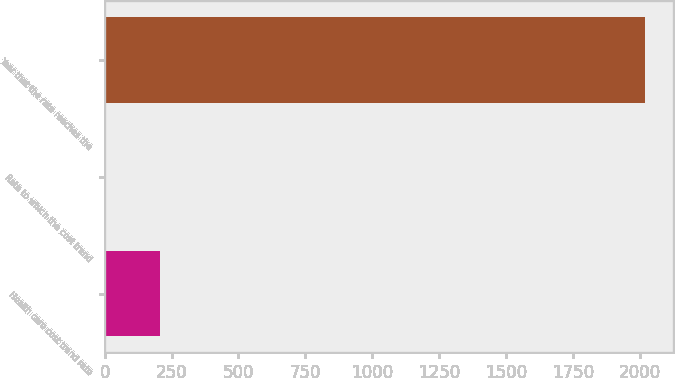<chart> <loc_0><loc_0><loc_500><loc_500><bar_chart><fcel>Health care cost trend rate<fcel>Rate to which the cost trend<fcel>Year that the rate reaches the<nl><fcel>206.6<fcel>5<fcel>2021<nl></chart> 